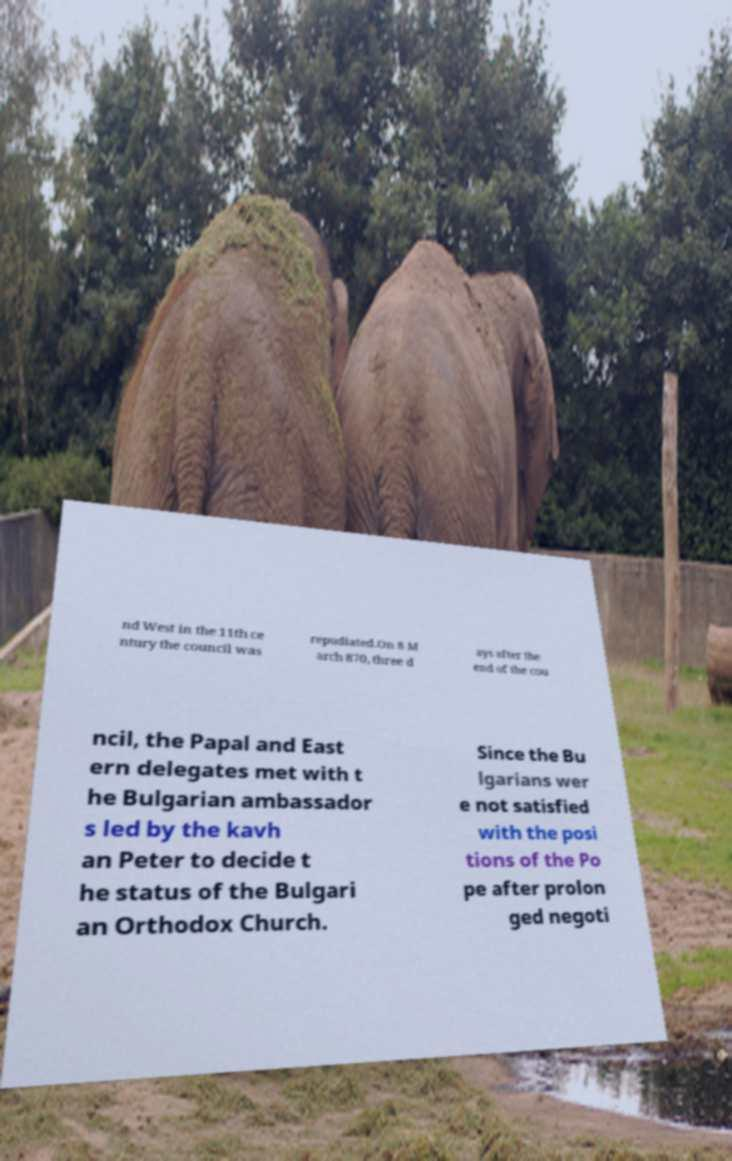I need the written content from this picture converted into text. Can you do that? nd West in the 11th ce ntury the council was repudiated.On 8 M arch 870, three d ays after the end of the cou ncil, the Papal and East ern delegates met with t he Bulgarian ambassador s led by the kavh an Peter to decide t he status of the Bulgari an Orthodox Church. Since the Bu lgarians wer e not satisfied with the posi tions of the Po pe after prolon ged negoti 